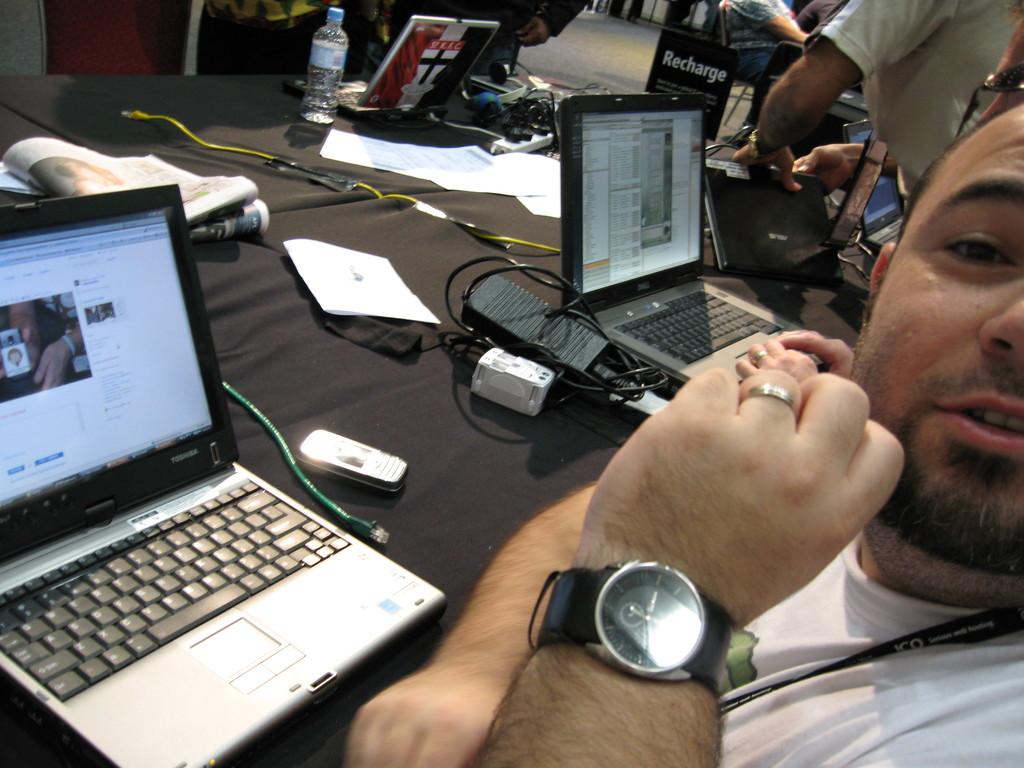Is he using a toshiba laptop?
Your answer should be very brief. Yes. What does the sign in the back say?
Offer a terse response. Recharge. 